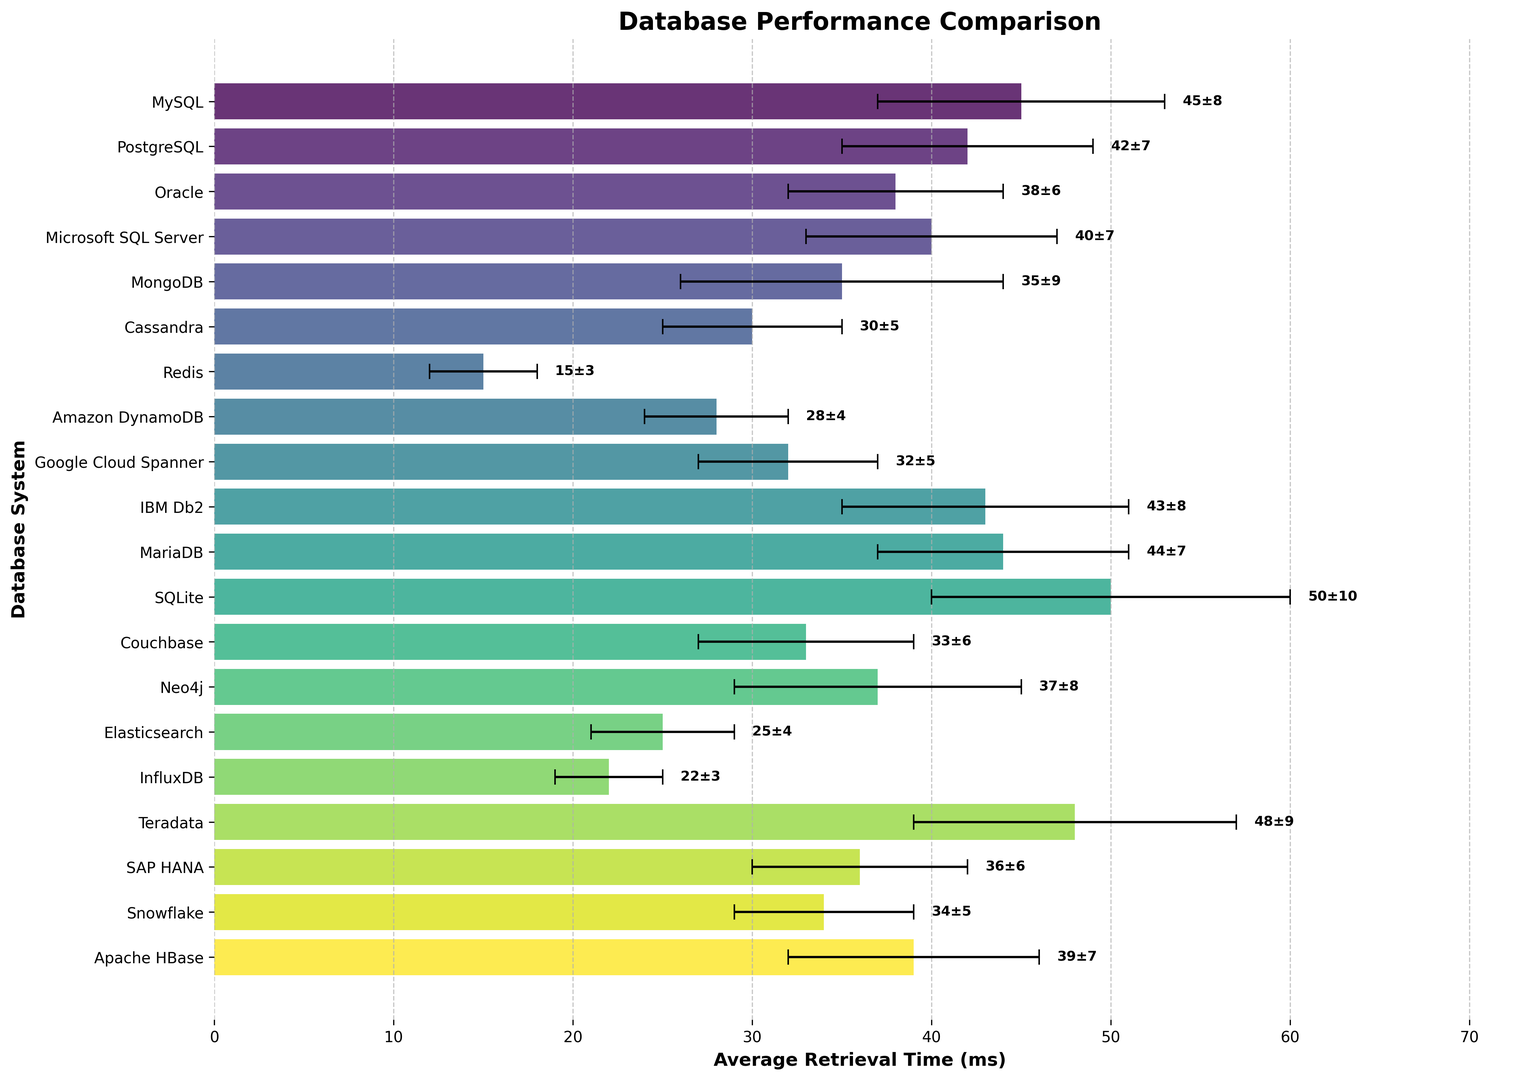Which database system has the shortest average data retrieval time? By observing the lengths of the bars, Redis has the shortest average data retrieval time, which is 15 ms.
Answer: Redis Which two database systems have the same standard deviation in retrieval times? By looking at the error bars, both MySQL and IBM Db2 have a standard deviation of 8 ms.
Answer: MySQL and IBM Db2 What is the difference in average retrieval time between Oracle and Couchbase? Oracle's average retrieval time is 38 ms and Couchbase's is 33 ms. The difference is calculated as 38 ms - 33 ms = 5 ms.
Answer: 5 ms Which database system has the highest average retrieval time and what is its average and standard deviation? By observing the bar lengths, SQLite has the highest average retrieval time, which is 50 ms with a standard deviation of 10 ms.
Answer: SQLite, 50 ms, 10 ms What is the range of the average retrieval times across all database systems? The highest average retrieval time is for SQLite at 50 ms, and the lowest is for Redis at 15 ms. The range is calculated as 50 ms - 15 ms = 35 ms.
Answer: 35 ms Which database system has a lower average retrieval time, Amazon DynamoDB or Google Cloud Spanner? Amazon DynamoDB has an average retrieval time of 28 ms, while Google Cloud Spanner has 32 ms. Therefore, Amazon DynamoDB has a lower retrieval time.
Answer: Amazon DynamoDB How many database systems have an average retrieval time less than 30 ms? By observing the lengths of the bars, Redis, Amazon DynamoDB, Cassandra, InfluxDB, and Elasticsearch have average retrieval times less than 30 ms. There are 5 such systems.
Answer: 5 systems If you were to choose between MariaDB and SAP HANA based solely on average retrieval time, which would you pick? MariaDB has an average retrieval time of 44 ms, while SAP HANA has 36 ms. SAP HANA has the lower average retrieval time.
Answer: SAP HANA What is the sum of the average retrieval times for Google Cloud Spanner and InfluxDB? Google Cloud Spanner has an average retrieval time of 32 ms and InfluxDB has 22 ms. The sum is calculated as 32 ms + 22 ms = 54 ms.
Answer: 54 ms 